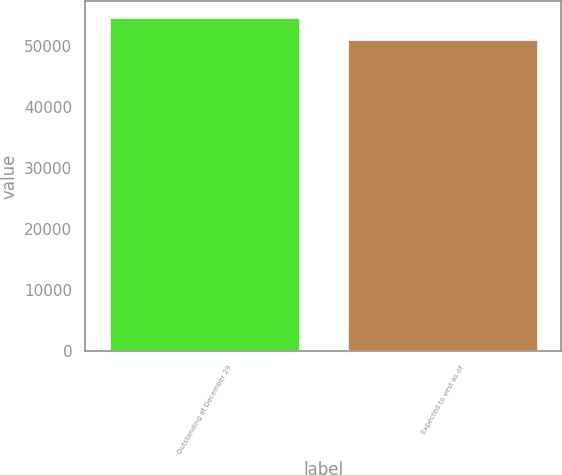<chart> <loc_0><loc_0><loc_500><loc_500><bar_chart><fcel>Outstanding at December 29<fcel>Expected to vest as of<nl><fcel>54710<fcel>51159<nl></chart> 